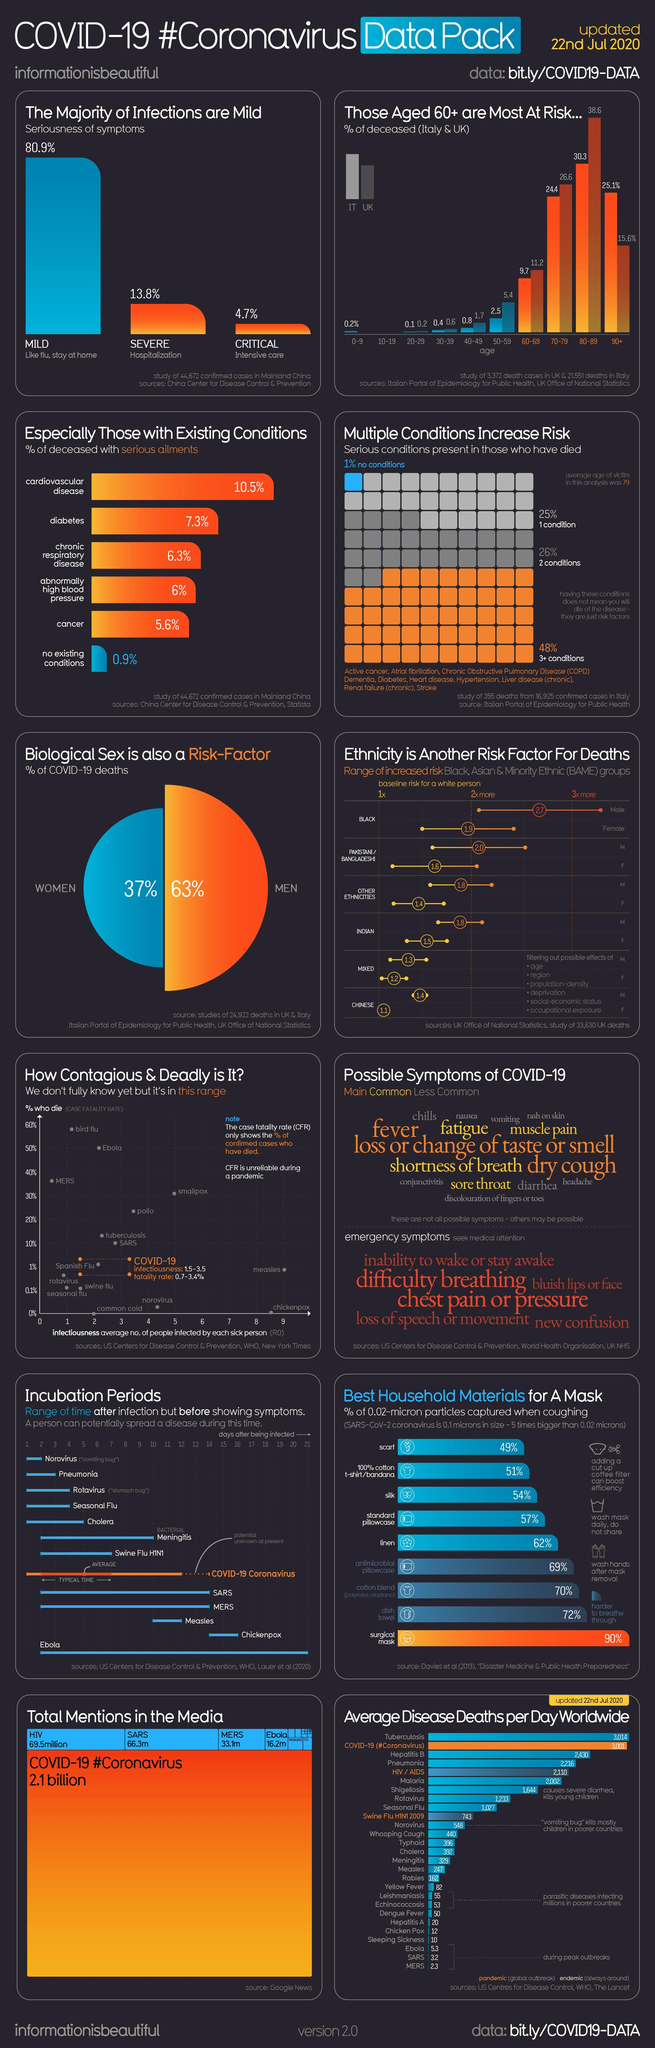People with second highest percentage of death/risk to die were having how many conditions?
Answer the question with a short phrase. 2 conditions If a COVID positive person has critical symptoms where he is advised to be admitted? Intensive Care What is the maximum no of persons whom can get infected from a Covid positive patient? 3.5 How many symptoms listed are the main symptoms of Corona? 3 What is the color code given to emergency symptoms of corona- blue, yellow, red, green? red Which is the best material mask to be wore during Corona? Surgical Mask Into how many categories Corona severity is classified? Mild, Severe, Critical Which is the second most common corona symptom that can even lead to death? diabetes What percentage of Covid patients are undergoing to critical situations? 4.7% 